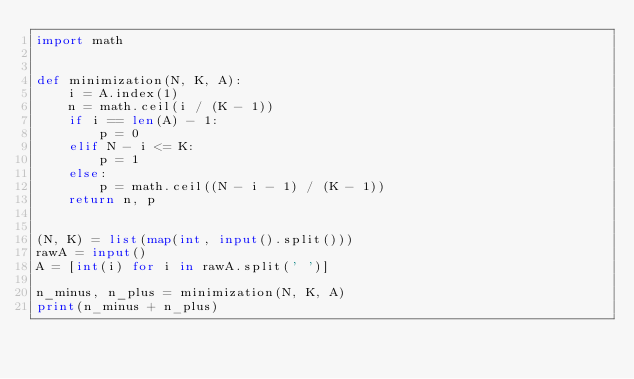<code> <loc_0><loc_0><loc_500><loc_500><_Python_>import math


def minimization(N, K, A):
    i = A.index(1)
    n = math.ceil(i / (K - 1))
    if i == len(A) - 1:
        p = 0
    elif N - i <= K:
        p = 1
    else:
        p = math.ceil((N - i - 1) / (K - 1))
    return n, p


(N, K) = list(map(int, input().split()))
rawA = input()
A = [int(i) for i in rawA.split(' ')]

n_minus, n_plus = minimization(N, K, A)
print(n_minus + n_plus)</code> 